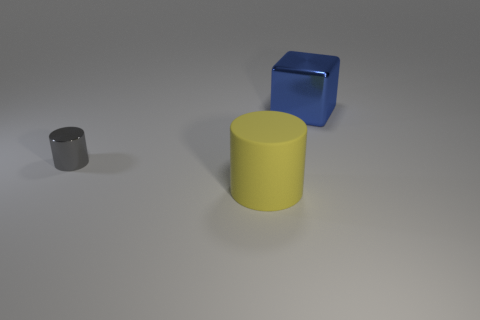How do the shadows in the image indicate the light source position? The shadows extend towards the lower right corner of the image, suggesting the light source is positioned to the upper left side, out of the frame, casting diffuse shadows consistent with ambient lighting.  Could these objects be used for educational purposes? Certainly, the distinct colors and simple geometric shapes of the objects could serve as didactic aids for teaching about colors, shapes, and spatial relationships in an educational setting. 